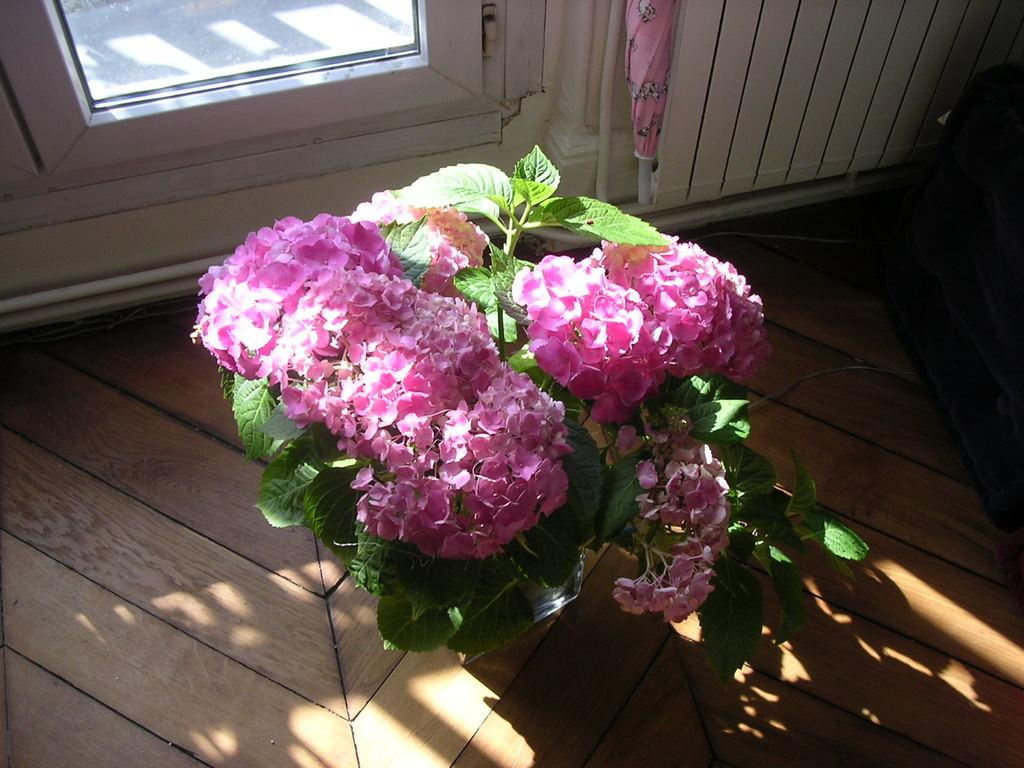What type of opening can be seen in the image? There is a window in the image. What type of structure is present in the image? There is a wall in the image. What object is used for protection from rain in the image? There is an umbrella in the image. What type of vegetation is present in the image? There is a plant in the image. What type of decorative element can be seen in the image? There are flowers in the image. What type of headgear is worn by the plant in the image? There is no headgear present in the image, as the plant is not a person or wearing any accessories. What type of iron object can be seen in the image? There is no iron object present in the image. 